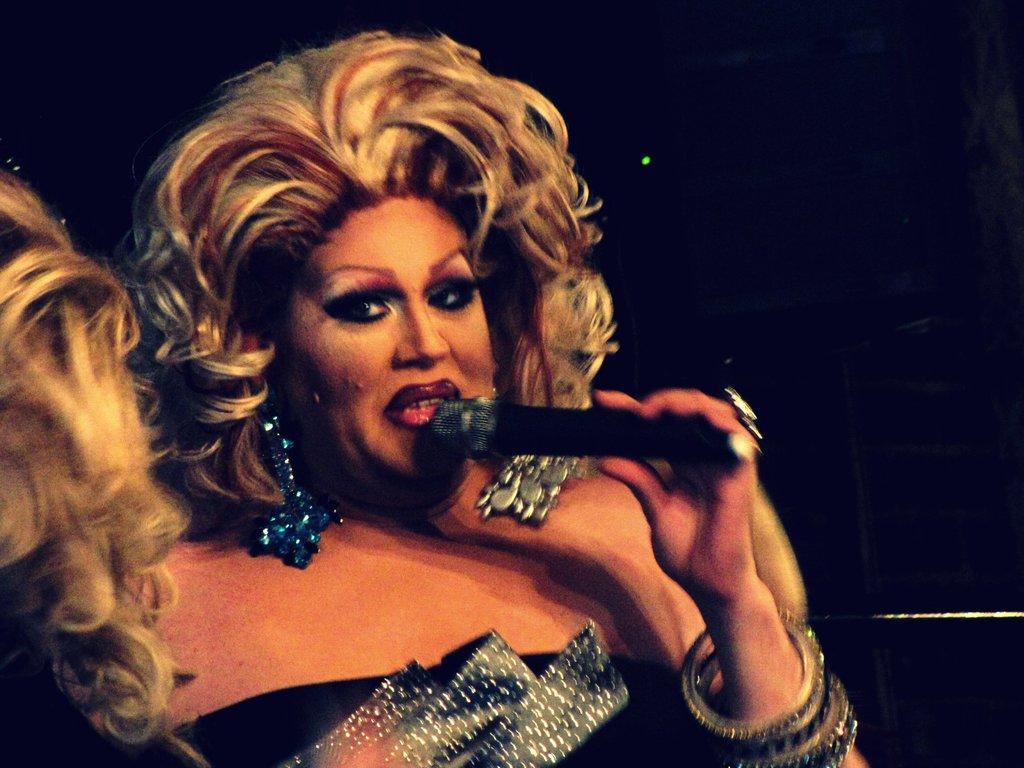How would you summarize this image in a sentence or two? The woman in front of the picture wearing a black dress and bangles is holding a microphone in her hand. I think she is talking on the microphone. Beside her, we see the hairs of the woman. In the background, it is black in color. 